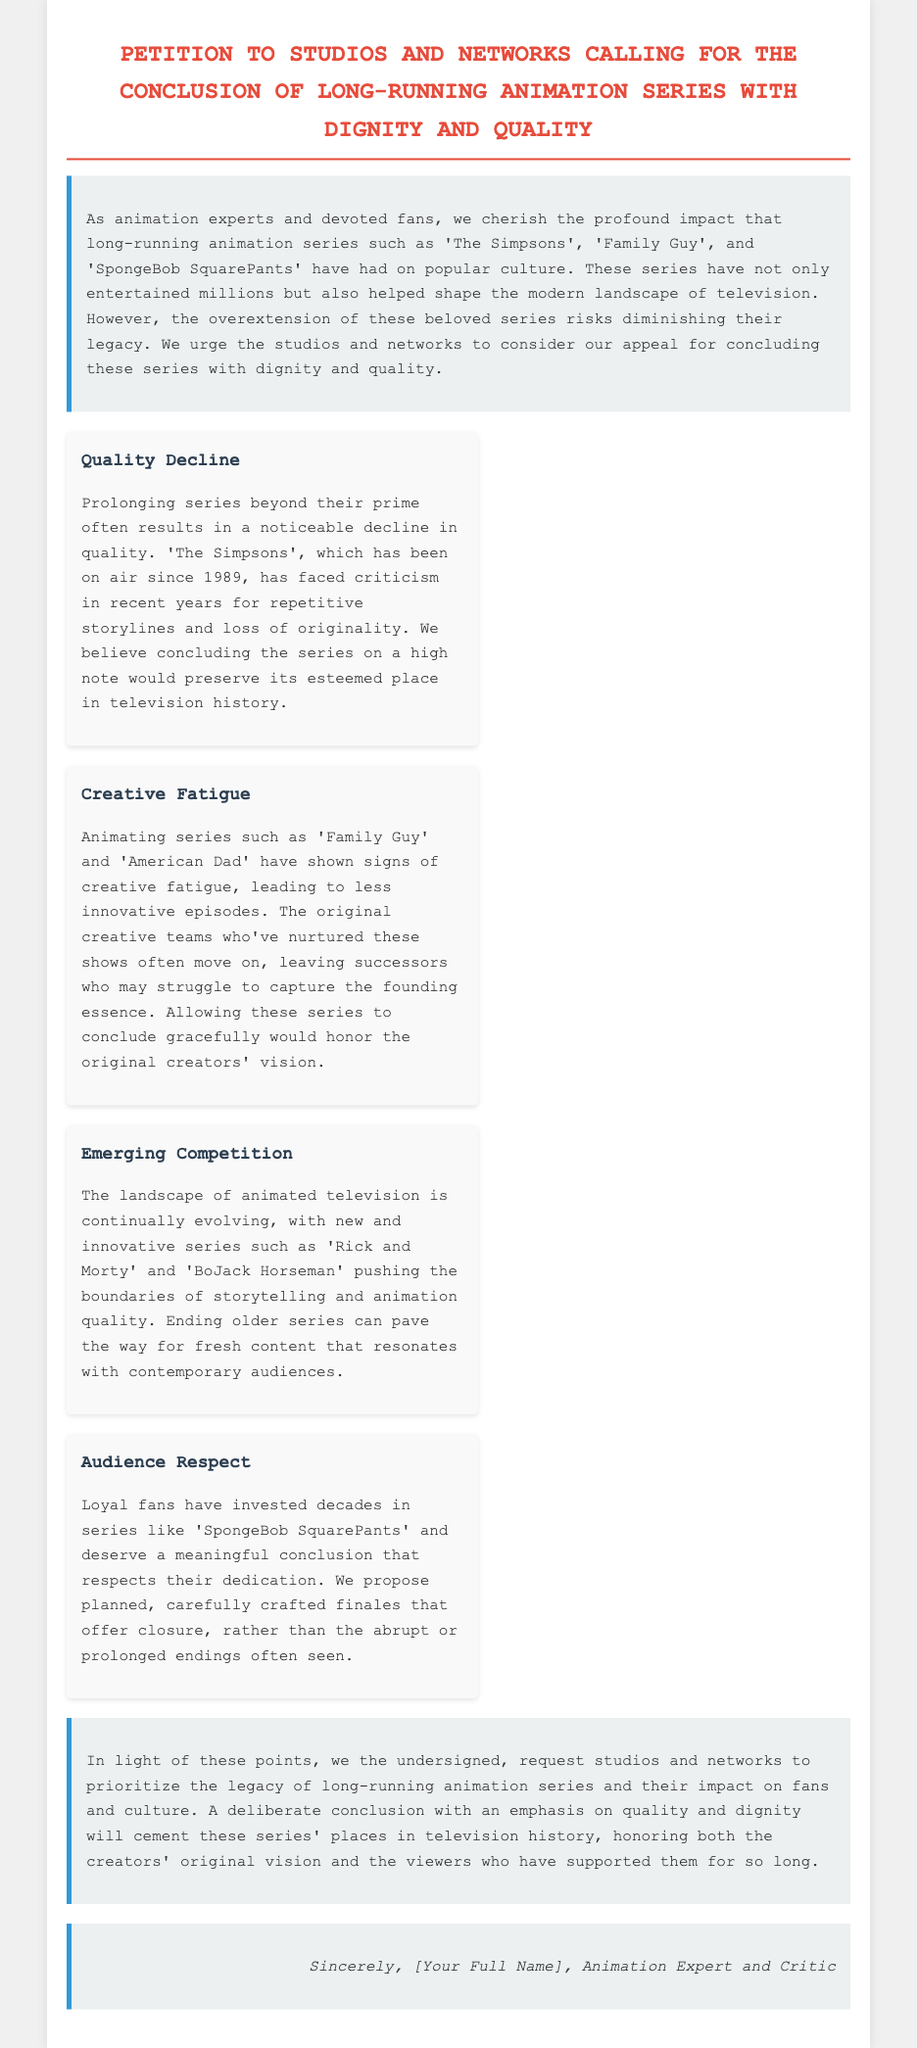What is the title of the petition? The title is explicitly stated at the beginning of the document, highlighting the focus on animation series.
Answer: Petition to Studios and Networks Calling for the Conclusion of Long-Running Animation Series with Dignity and Quality Which animation series is mentioned as an example of a long-running show? The document lists specific examples of long-running animation series that have impacted popular culture.
Answer: The Simpsons What year did 'The Simpsons' first air? The document references 'The Simpsons' and its starting year, which signifies its long tenure in animation.
Answer: 1989 What is one of the main points listed in the petition? Each section of the main points discusses a specific concern related to the overextension of animation series.
Answer: Quality Decline What kind of conclusion does the petition advocate for? The conclusion highlights what the petitioners believe should be done when concluding long-running shows.
Answer: Meaningful conclusion How do the petitioners feel about the current state of creativity in animated series? The document expresses a specific concern regarding the creative direction of certain series.
Answer: Creative fatigue How do petitioners suggest treating the audience in regard to series endings? The petition emphasizes the importance of respecting the audience's investment in these long-running series.
Answer: Meaningful conclusion What is the significance of emerging competition according to the petition? The petition discusses new animated series and their role in shifting the landscape of television.
Answer: Fresh content Who is signing off the petition? The sign-off section indicates the identity of the person associated with the petition, signifying their role.
Answer: Animation Expert and Critic 